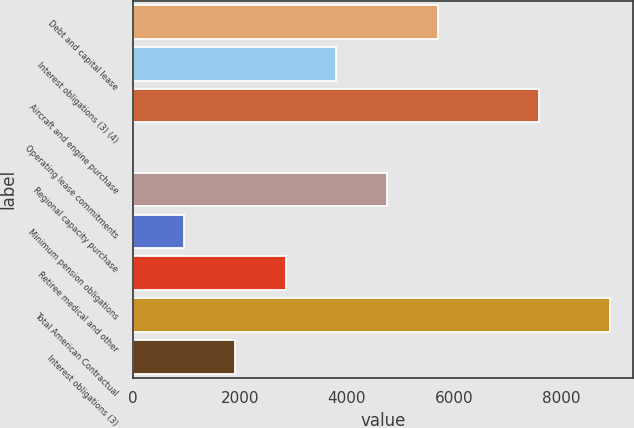<chart> <loc_0><loc_0><loc_500><loc_500><bar_chart><fcel>Debt and capital lease<fcel>Interest obligations (3) (4)<fcel>Aircraft and engine purchase<fcel>Operating lease commitments<fcel>Regional capacity purchase<fcel>Minimum pension obligations<fcel>Retiree medical and other<fcel>Total American Contractual<fcel>Interest obligations (3)<nl><fcel>5698.8<fcel>3801.2<fcel>7596.4<fcel>6<fcel>4750<fcel>954.8<fcel>2852.4<fcel>8906<fcel>1903.6<nl></chart> 